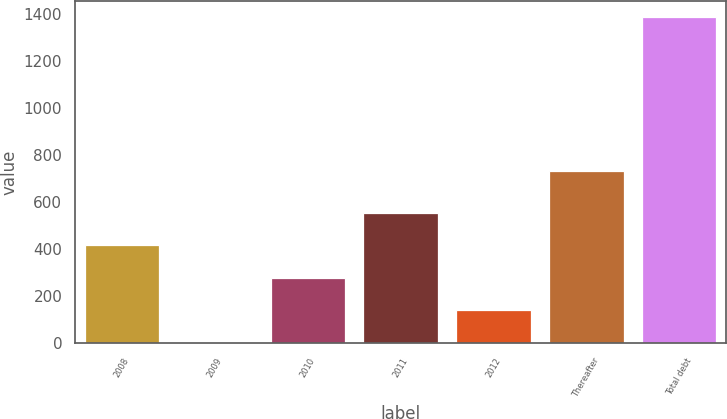Convert chart to OTSL. <chart><loc_0><loc_0><loc_500><loc_500><bar_chart><fcel>2008<fcel>2009<fcel>2010<fcel>2011<fcel>2012<fcel>Thereafter<fcel>Total debt<nl><fcel>416.94<fcel>2.4<fcel>278.76<fcel>555.12<fcel>140.58<fcel>732.5<fcel>1384.2<nl></chart> 